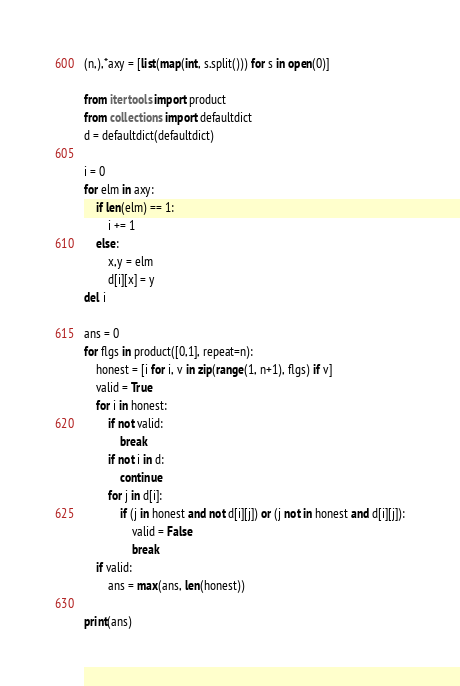Convert code to text. <code><loc_0><loc_0><loc_500><loc_500><_Python_>(n,),*axy = [list(map(int, s.split())) for s in open(0)]

from itertools import product
from collections import defaultdict
d = defaultdict(defaultdict)

i = 0
for elm in axy:
    if len(elm) == 1:
        i += 1
    else:
        x,y = elm
        d[i][x] = y
del i

ans = 0
for flgs in product([0,1], repeat=n):
    honest = [i for i, v in zip(range(1, n+1), flgs) if v]
    valid = True
    for i in honest:
        if not valid:
            break
        if not i in d:
            continue
        for j in d[i]:
            if (j in honest and not d[i][j]) or (j not in honest and d[i][j]):
                valid = False
                break
    if valid:
        ans = max(ans, len(honest))

print(ans)</code> 